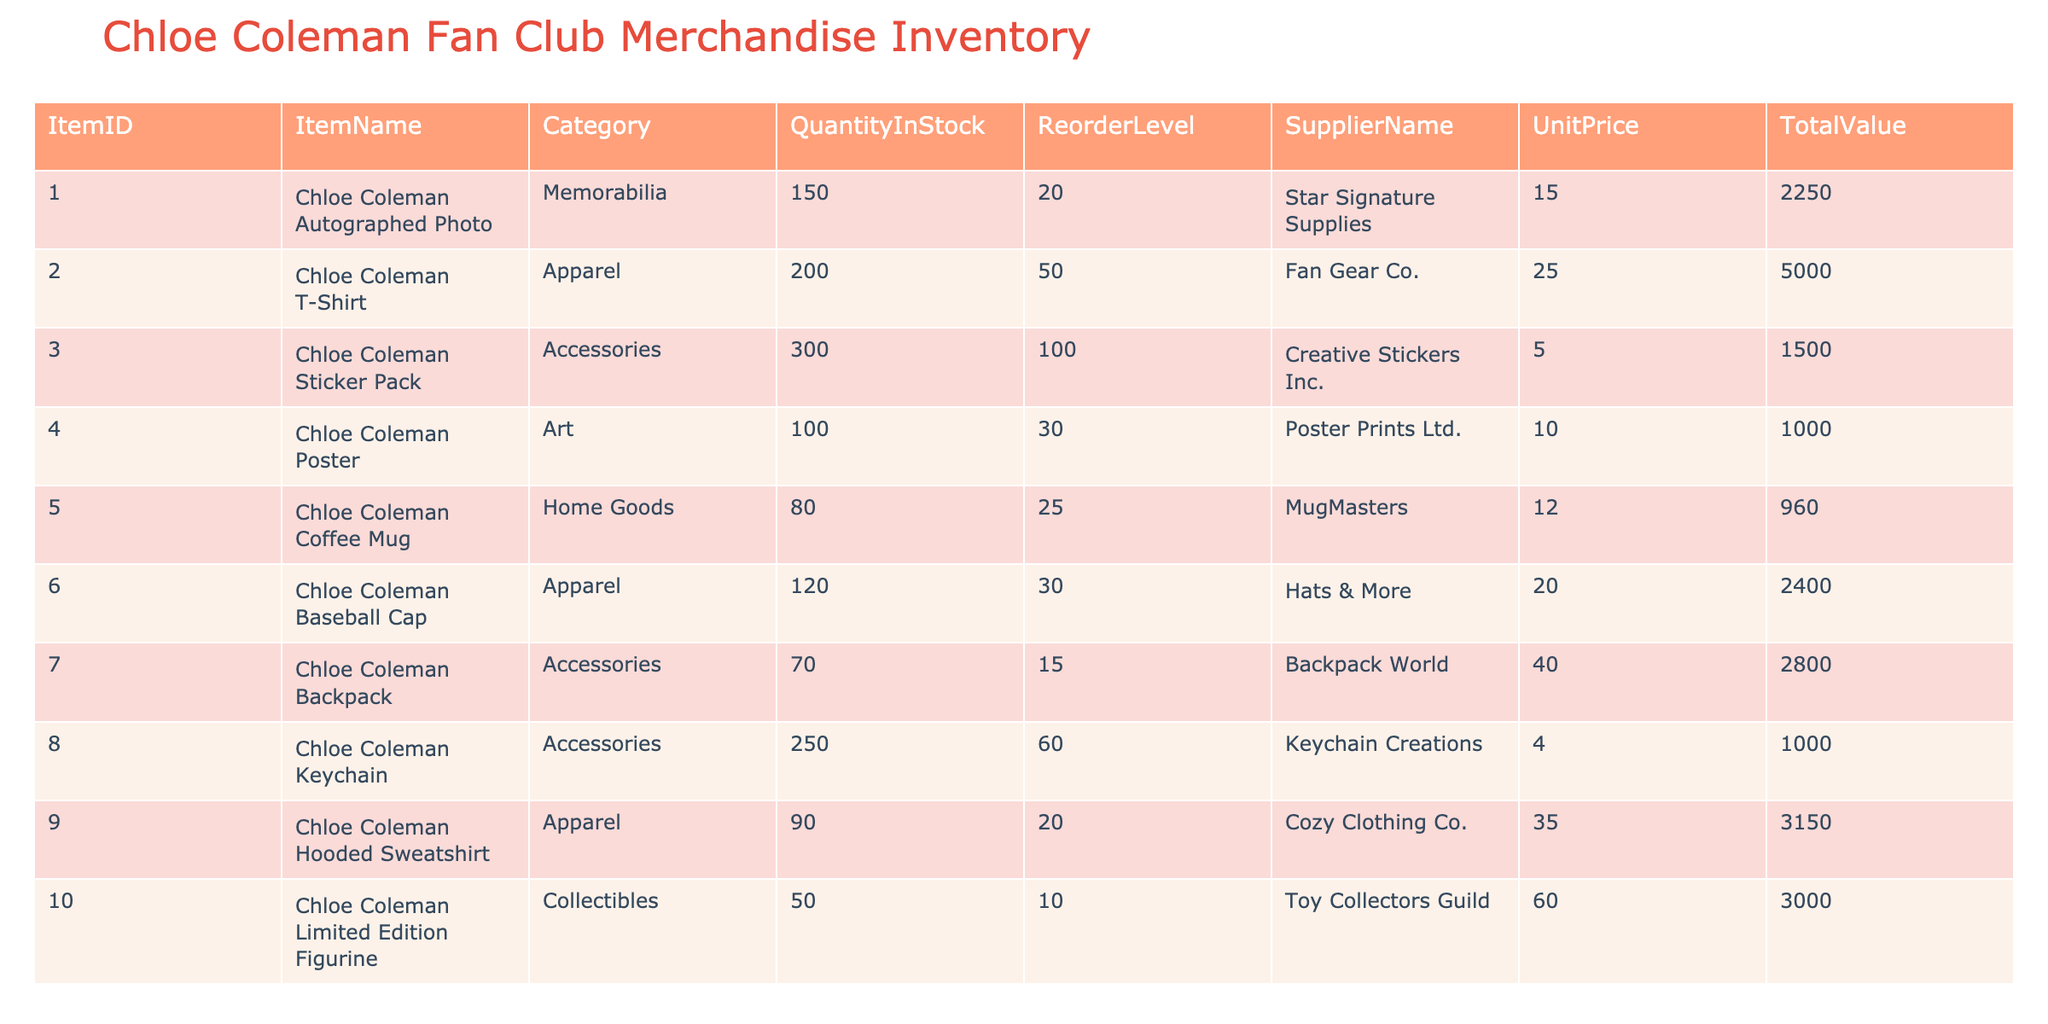What is the total quantity of all items in stock? To find the total quantity, sum the quantities in the QuantityInStock column: 150 + 200 + 300 + 100 + 80 + 120 + 70 + 250 + 90 + 50 = 1,510
Answer: 1510 Which item has the highest unit price? Reviewing the UnitPrice column, the Chloe Coleman Limited Edition Figurine has the highest unit price of 60.00
Answer: Chloe Coleman Limited Edition Figurine Is the quantity in stock for the Chloe Coleman Coffee Mug above its reorder level? The stock for the Chloe Coleman Coffee Mug is 80, and its reorder level is 25. Since 80 is greater than 25, the statement is true
Answer: Yes How many items fall under the Apparel category? Filtering the table for items in the Apparel category, we find three items: Chloe Coleman T-Shirt, Chloe Coleman Baseball Cap, and Chloe Coleman Hooded Sweatshirt. Therefore, the count is 3
Answer: 3 What is the total value of the Accessories category items? To calculate this, sum the TotalValue of items categorized as Accessories: 1,500 + 2,800 + 1,000 = 5,300. Therefore, the total value is 5,300
Answer: 5300 Is the quantity in stock for Chloe Coleman Backpack less than the reorder level? The stock quantity for the Chloe Coleman Backpack is 70, and its reorder level is 15. Since 70 is greater than 15, the statement is false
Answer: No Which category has the least quantity in stock? By comparing quantities across categories, the Collectibles category has only 50 in stock, which is less than other categories. Thus, it has the least stock
Answer: Collectibles What is the average unit price of all items in stock? To find the average, sum all unit prices: (15 + 25 + 5 + 10 + 12 + 20 + 40 + 4 + 35 + 60) = 221; then divide by the number of items (10). Therefore, 221 / 10 = 22.1
Answer: 22.1 What item requires ordering based on its reorder level? By checking the QuantityInStock against the ReorderLevel, the Chloe Coleman Limited Edition Figurine has 50 in stock and a reorder level of 10. Hence, this item does need to be reordered
Answer: Yes 